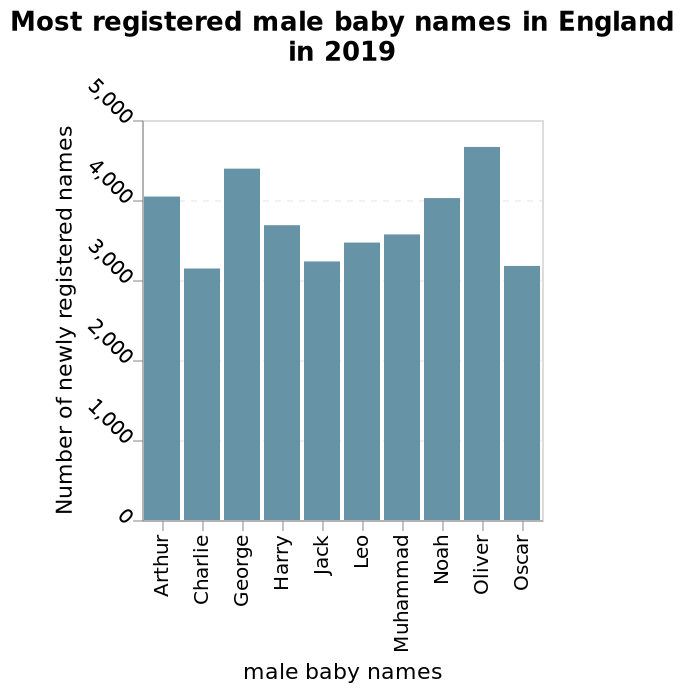<image>
Which name had the highest number of newly registered male babies in England in 2019?  The bar graph does not provide specific information about the highest number of newly registered male babies for a particular name. It only represents the overall distribution of names from Arthur to Oscar. What is the minimum number of newly registered male baby names in England in 2019?  The minimum number of newly registered male baby names in England in 2019 is 0. 